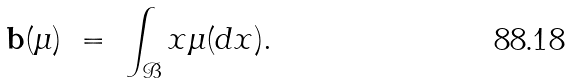<formula> <loc_0><loc_0><loc_500><loc_500>\mathbf b ( \mu ) \ = \ \int _ { \mathcal { B } } x \mu ( d x ) .</formula> 